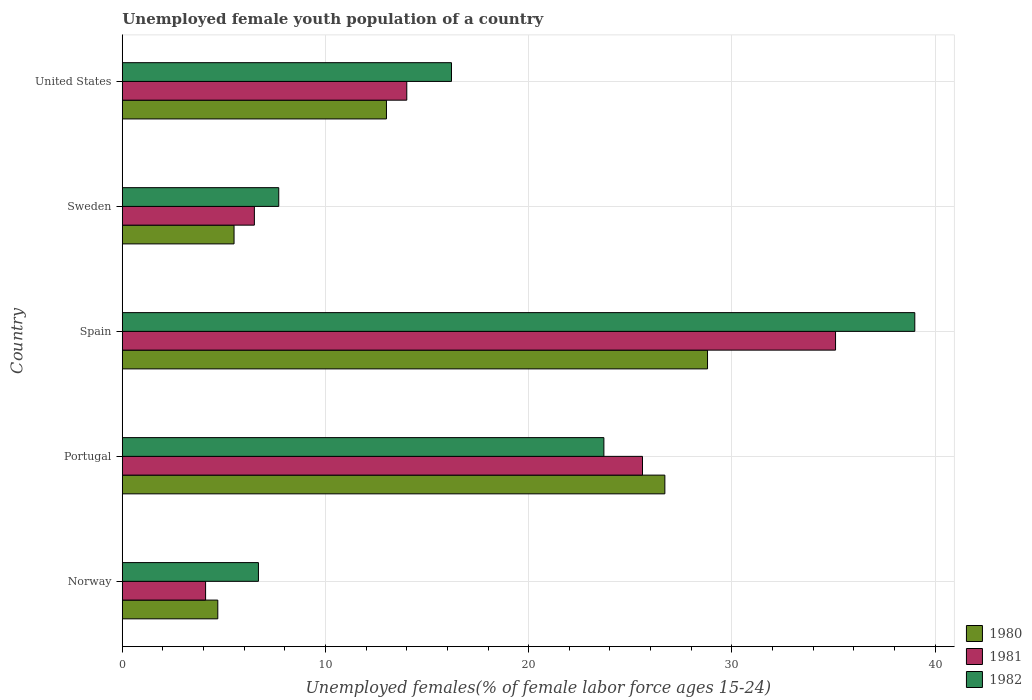How many groups of bars are there?
Offer a terse response. 5. Are the number of bars per tick equal to the number of legend labels?
Your response must be concise. Yes. How many bars are there on the 4th tick from the top?
Ensure brevity in your answer.  3. In how many cases, is the number of bars for a given country not equal to the number of legend labels?
Your response must be concise. 0. What is the percentage of unemployed female youth population in 1980 in Sweden?
Provide a succinct answer. 5.5. Across all countries, what is the maximum percentage of unemployed female youth population in 1981?
Offer a very short reply. 35.1. Across all countries, what is the minimum percentage of unemployed female youth population in 1981?
Offer a very short reply. 4.1. What is the total percentage of unemployed female youth population in 1981 in the graph?
Make the answer very short. 85.3. What is the difference between the percentage of unemployed female youth population in 1981 in Spain and that in United States?
Keep it short and to the point. 21.1. What is the difference between the percentage of unemployed female youth population in 1982 in United States and the percentage of unemployed female youth population in 1981 in Portugal?
Your answer should be very brief. -9.4. What is the average percentage of unemployed female youth population in 1980 per country?
Offer a very short reply. 15.74. What is the difference between the percentage of unemployed female youth population in 1980 and percentage of unemployed female youth population in 1981 in Spain?
Give a very brief answer. -6.3. In how many countries, is the percentage of unemployed female youth population in 1980 greater than 18 %?
Provide a short and direct response. 2. What is the ratio of the percentage of unemployed female youth population in 1981 in Spain to that in United States?
Keep it short and to the point. 2.51. What is the difference between the highest and the second highest percentage of unemployed female youth population in 1982?
Give a very brief answer. 15.3. What is the difference between the highest and the lowest percentage of unemployed female youth population in 1981?
Make the answer very short. 31. Is it the case that in every country, the sum of the percentage of unemployed female youth population in 1981 and percentage of unemployed female youth population in 1980 is greater than the percentage of unemployed female youth population in 1982?
Ensure brevity in your answer.  Yes. Are all the bars in the graph horizontal?
Ensure brevity in your answer.  Yes. How many countries are there in the graph?
Ensure brevity in your answer.  5. Are the values on the major ticks of X-axis written in scientific E-notation?
Provide a succinct answer. No. Does the graph contain any zero values?
Your answer should be very brief. No. How many legend labels are there?
Keep it short and to the point. 3. What is the title of the graph?
Keep it short and to the point. Unemployed female youth population of a country. What is the label or title of the X-axis?
Your answer should be compact. Unemployed females(% of female labor force ages 15-24). What is the label or title of the Y-axis?
Your answer should be compact. Country. What is the Unemployed females(% of female labor force ages 15-24) of 1980 in Norway?
Give a very brief answer. 4.7. What is the Unemployed females(% of female labor force ages 15-24) in 1981 in Norway?
Offer a terse response. 4.1. What is the Unemployed females(% of female labor force ages 15-24) of 1982 in Norway?
Give a very brief answer. 6.7. What is the Unemployed females(% of female labor force ages 15-24) in 1980 in Portugal?
Your answer should be very brief. 26.7. What is the Unemployed females(% of female labor force ages 15-24) in 1981 in Portugal?
Your answer should be compact. 25.6. What is the Unemployed females(% of female labor force ages 15-24) of 1982 in Portugal?
Your response must be concise. 23.7. What is the Unemployed females(% of female labor force ages 15-24) in 1980 in Spain?
Make the answer very short. 28.8. What is the Unemployed females(% of female labor force ages 15-24) in 1981 in Spain?
Give a very brief answer. 35.1. What is the Unemployed females(% of female labor force ages 15-24) in 1980 in Sweden?
Give a very brief answer. 5.5. What is the Unemployed females(% of female labor force ages 15-24) of 1981 in Sweden?
Make the answer very short. 6.5. What is the Unemployed females(% of female labor force ages 15-24) of 1982 in Sweden?
Make the answer very short. 7.7. What is the Unemployed females(% of female labor force ages 15-24) of 1980 in United States?
Offer a very short reply. 13. What is the Unemployed females(% of female labor force ages 15-24) of 1981 in United States?
Your answer should be compact. 14. What is the Unemployed females(% of female labor force ages 15-24) of 1982 in United States?
Provide a succinct answer. 16.2. Across all countries, what is the maximum Unemployed females(% of female labor force ages 15-24) of 1980?
Give a very brief answer. 28.8. Across all countries, what is the maximum Unemployed females(% of female labor force ages 15-24) in 1981?
Make the answer very short. 35.1. Across all countries, what is the minimum Unemployed females(% of female labor force ages 15-24) of 1980?
Make the answer very short. 4.7. Across all countries, what is the minimum Unemployed females(% of female labor force ages 15-24) of 1981?
Your response must be concise. 4.1. Across all countries, what is the minimum Unemployed females(% of female labor force ages 15-24) in 1982?
Provide a short and direct response. 6.7. What is the total Unemployed females(% of female labor force ages 15-24) in 1980 in the graph?
Make the answer very short. 78.7. What is the total Unemployed females(% of female labor force ages 15-24) of 1981 in the graph?
Give a very brief answer. 85.3. What is the total Unemployed females(% of female labor force ages 15-24) in 1982 in the graph?
Offer a terse response. 93.3. What is the difference between the Unemployed females(% of female labor force ages 15-24) in 1980 in Norway and that in Portugal?
Provide a succinct answer. -22. What is the difference between the Unemployed females(% of female labor force ages 15-24) of 1981 in Norway and that in Portugal?
Offer a very short reply. -21.5. What is the difference between the Unemployed females(% of female labor force ages 15-24) in 1980 in Norway and that in Spain?
Offer a terse response. -24.1. What is the difference between the Unemployed females(% of female labor force ages 15-24) in 1981 in Norway and that in Spain?
Ensure brevity in your answer.  -31. What is the difference between the Unemployed females(% of female labor force ages 15-24) in 1982 in Norway and that in Spain?
Ensure brevity in your answer.  -32.3. What is the difference between the Unemployed females(% of female labor force ages 15-24) of 1981 in Norway and that in Sweden?
Provide a succinct answer. -2.4. What is the difference between the Unemployed females(% of female labor force ages 15-24) in 1982 in Norway and that in United States?
Your answer should be very brief. -9.5. What is the difference between the Unemployed females(% of female labor force ages 15-24) in 1981 in Portugal and that in Spain?
Keep it short and to the point. -9.5. What is the difference between the Unemployed females(% of female labor force ages 15-24) in 1982 in Portugal and that in Spain?
Provide a succinct answer. -15.3. What is the difference between the Unemployed females(% of female labor force ages 15-24) of 1980 in Portugal and that in Sweden?
Make the answer very short. 21.2. What is the difference between the Unemployed females(% of female labor force ages 15-24) of 1982 in Portugal and that in Sweden?
Your answer should be compact. 16. What is the difference between the Unemployed females(% of female labor force ages 15-24) in 1980 in Portugal and that in United States?
Ensure brevity in your answer.  13.7. What is the difference between the Unemployed females(% of female labor force ages 15-24) in 1981 in Portugal and that in United States?
Keep it short and to the point. 11.6. What is the difference between the Unemployed females(% of female labor force ages 15-24) in 1982 in Portugal and that in United States?
Provide a succinct answer. 7.5. What is the difference between the Unemployed females(% of female labor force ages 15-24) of 1980 in Spain and that in Sweden?
Make the answer very short. 23.3. What is the difference between the Unemployed females(% of female labor force ages 15-24) in 1981 in Spain and that in Sweden?
Provide a short and direct response. 28.6. What is the difference between the Unemployed females(% of female labor force ages 15-24) in 1982 in Spain and that in Sweden?
Your answer should be very brief. 31.3. What is the difference between the Unemployed females(% of female labor force ages 15-24) in 1981 in Spain and that in United States?
Offer a very short reply. 21.1. What is the difference between the Unemployed females(% of female labor force ages 15-24) in 1982 in Spain and that in United States?
Give a very brief answer. 22.8. What is the difference between the Unemployed females(% of female labor force ages 15-24) of 1982 in Sweden and that in United States?
Give a very brief answer. -8.5. What is the difference between the Unemployed females(% of female labor force ages 15-24) of 1980 in Norway and the Unemployed females(% of female labor force ages 15-24) of 1981 in Portugal?
Offer a terse response. -20.9. What is the difference between the Unemployed females(% of female labor force ages 15-24) of 1981 in Norway and the Unemployed females(% of female labor force ages 15-24) of 1982 in Portugal?
Your answer should be very brief. -19.6. What is the difference between the Unemployed females(% of female labor force ages 15-24) in 1980 in Norway and the Unemployed females(% of female labor force ages 15-24) in 1981 in Spain?
Give a very brief answer. -30.4. What is the difference between the Unemployed females(% of female labor force ages 15-24) in 1980 in Norway and the Unemployed females(% of female labor force ages 15-24) in 1982 in Spain?
Offer a terse response. -34.3. What is the difference between the Unemployed females(% of female labor force ages 15-24) of 1981 in Norway and the Unemployed females(% of female labor force ages 15-24) of 1982 in Spain?
Your answer should be very brief. -34.9. What is the difference between the Unemployed females(% of female labor force ages 15-24) of 1981 in Norway and the Unemployed females(% of female labor force ages 15-24) of 1982 in United States?
Keep it short and to the point. -12.1. What is the difference between the Unemployed females(% of female labor force ages 15-24) of 1980 in Portugal and the Unemployed females(% of female labor force ages 15-24) of 1982 in Spain?
Give a very brief answer. -12.3. What is the difference between the Unemployed females(% of female labor force ages 15-24) of 1981 in Portugal and the Unemployed females(% of female labor force ages 15-24) of 1982 in Spain?
Provide a short and direct response. -13.4. What is the difference between the Unemployed females(% of female labor force ages 15-24) in 1980 in Portugal and the Unemployed females(% of female labor force ages 15-24) in 1981 in Sweden?
Your response must be concise. 20.2. What is the difference between the Unemployed females(% of female labor force ages 15-24) in 1980 in Portugal and the Unemployed females(% of female labor force ages 15-24) in 1981 in United States?
Your answer should be very brief. 12.7. What is the difference between the Unemployed females(% of female labor force ages 15-24) of 1980 in Portugal and the Unemployed females(% of female labor force ages 15-24) of 1982 in United States?
Your answer should be compact. 10.5. What is the difference between the Unemployed females(% of female labor force ages 15-24) in 1980 in Spain and the Unemployed females(% of female labor force ages 15-24) in 1981 in Sweden?
Your answer should be very brief. 22.3. What is the difference between the Unemployed females(% of female labor force ages 15-24) of 1980 in Spain and the Unemployed females(% of female labor force ages 15-24) of 1982 in Sweden?
Your answer should be compact. 21.1. What is the difference between the Unemployed females(% of female labor force ages 15-24) in 1981 in Spain and the Unemployed females(% of female labor force ages 15-24) in 1982 in Sweden?
Provide a short and direct response. 27.4. What is the difference between the Unemployed females(% of female labor force ages 15-24) of 1980 in Spain and the Unemployed females(% of female labor force ages 15-24) of 1982 in United States?
Offer a terse response. 12.6. What is the difference between the Unemployed females(% of female labor force ages 15-24) in 1980 in Sweden and the Unemployed females(% of female labor force ages 15-24) in 1981 in United States?
Make the answer very short. -8.5. What is the difference between the Unemployed females(% of female labor force ages 15-24) in 1980 in Sweden and the Unemployed females(% of female labor force ages 15-24) in 1982 in United States?
Offer a terse response. -10.7. What is the difference between the Unemployed females(% of female labor force ages 15-24) in 1981 in Sweden and the Unemployed females(% of female labor force ages 15-24) in 1982 in United States?
Keep it short and to the point. -9.7. What is the average Unemployed females(% of female labor force ages 15-24) of 1980 per country?
Your answer should be very brief. 15.74. What is the average Unemployed females(% of female labor force ages 15-24) in 1981 per country?
Make the answer very short. 17.06. What is the average Unemployed females(% of female labor force ages 15-24) in 1982 per country?
Your answer should be very brief. 18.66. What is the difference between the Unemployed females(% of female labor force ages 15-24) in 1981 and Unemployed females(% of female labor force ages 15-24) in 1982 in Portugal?
Your answer should be compact. 1.9. What is the difference between the Unemployed females(% of female labor force ages 15-24) of 1981 and Unemployed females(% of female labor force ages 15-24) of 1982 in Spain?
Make the answer very short. -3.9. What is the difference between the Unemployed females(% of female labor force ages 15-24) of 1981 and Unemployed females(% of female labor force ages 15-24) of 1982 in Sweden?
Your response must be concise. -1.2. What is the difference between the Unemployed females(% of female labor force ages 15-24) of 1980 and Unemployed females(% of female labor force ages 15-24) of 1981 in United States?
Your answer should be very brief. -1. What is the ratio of the Unemployed females(% of female labor force ages 15-24) in 1980 in Norway to that in Portugal?
Keep it short and to the point. 0.18. What is the ratio of the Unemployed females(% of female labor force ages 15-24) in 1981 in Norway to that in Portugal?
Offer a very short reply. 0.16. What is the ratio of the Unemployed females(% of female labor force ages 15-24) of 1982 in Norway to that in Portugal?
Give a very brief answer. 0.28. What is the ratio of the Unemployed females(% of female labor force ages 15-24) of 1980 in Norway to that in Spain?
Offer a terse response. 0.16. What is the ratio of the Unemployed females(% of female labor force ages 15-24) in 1981 in Norway to that in Spain?
Make the answer very short. 0.12. What is the ratio of the Unemployed females(% of female labor force ages 15-24) of 1982 in Norway to that in Spain?
Make the answer very short. 0.17. What is the ratio of the Unemployed females(% of female labor force ages 15-24) in 1980 in Norway to that in Sweden?
Offer a very short reply. 0.85. What is the ratio of the Unemployed females(% of female labor force ages 15-24) in 1981 in Norway to that in Sweden?
Give a very brief answer. 0.63. What is the ratio of the Unemployed females(% of female labor force ages 15-24) in 1982 in Norway to that in Sweden?
Make the answer very short. 0.87. What is the ratio of the Unemployed females(% of female labor force ages 15-24) of 1980 in Norway to that in United States?
Provide a succinct answer. 0.36. What is the ratio of the Unemployed females(% of female labor force ages 15-24) of 1981 in Norway to that in United States?
Provide a short and direct response. 0.29. What is the ratio of the Unemployed females(% of female labor force ages 15-24) of 1982 in Norway to that in United States?
Your response must be concise. 0.41. What is the ratio of the Unemployed females(% of female labor force ages 15-24) of 1980 in Portugal to that in Spain?
Make the answer very short. 0.93. What is the ratio of the Unemployed females(% of female labor force ages 15-24) of 1981 in Portugal to that in Spain?
Your response must be concise. 0.73. What is the ratio of the Unemployed females(% of female labor force ages 15-24) in 1982 in Portugal to that in Spain?
Ensure brevity in your answer.  0.61. What is the ratio of the Unemployed females(% of female labor force ages 15-24) in 1980 in Portugal to that in Sweden?
Make the answer very short. 4.85. What is the ratio of the Unemployed females(% of female labor force ages 15-24) in 1981 in Portugal to that in Sweden?
Keep it short and to the point. 3.94. What is the ratio of the Unemployed females(% of female labor force ages 15-24) of 1982 in Portugal to that in Sweden?
Your answer should be very brief. 3.08. What is the ratio of the Unemployed females(% of female labor force ages 15-24) of 1980 in Portugal to that in United States?
Your response must be concise. 2.05. What is the ratio of the Unemployed females(% of female labor force ages 15-24) in 1981 in Portugal to that in United States?
Provide a succinct answer. 1.83. What is the ratio of the Unemployed females(% of female labor force ages 15-24) in 1982 in Portugal to that in United States?
Provide a short and direct response. 1.46. What is the ratio of the Unemployed females(% of female labor force ages 15-24) of 1980 in Spain to that in Sweden?
Your answer should be very brief. 5.24. What is the ratio of the Unemployed females(% of female labor force ages 15-24) in 1981 in Spain to that in Sweden?
Offer a terse response. 5.4. What is the ratio of the Unemployed females(% of female labor force ages 15-24) in 1982 in Spain to that in Sweden?
Your answer should be very brief. 5.06. What is the ratio of the Unemployed females(% of female labor force ages 15-24) in 1980 in Spain to that in United States?
Keep it short and to the point. 2.22. What is the ratio of the Unemployed females(% of female labor force ages 15-24) in 1981 in Spain to that in United States?
Ensure brevity in your answer.  2.51. What is the ratio of the Unemployed females(% of female labor force ages 15-24) in 1982 in Spain to that in United States?
Make the answer very short. 2.41. What is the ratio of the Unemployed females(% of female labor force ages 15-24) in 1980 in Sweden to that in United States?
Keep it short and to the point. 0.42. What is the ratio of the Unemployed females(% of female labor force ages 15-24) in 1981 in Sweden to that in United States?
Give a very brief answer. 0.46. What is the ratio of the Unemployed females(% of female labor force ages 15-24) of 1982 in Sweden to that in United States?
Keep it short and to the point. 0.48. What is the difference between the highest and the second highest Unemployed females(% of female labor force ages 15-24) of 1980?
Give a very brief answer. 2.1. What is the difference between the highest and the second highest Unemployed females(% of female labor force ages 15-24) of 1981?
Make the answer very short. 9.5. What is the difference between the highest and the lowest Unemployed females(% of female labor force ages 15-24) of 1980?
Provide a succinct answer. 24.1. What is the difference between the highest and the lowest Unemployed females(% of female labor force ages 15-24) in 1982?
Keep it short and to the point. 32.3. 